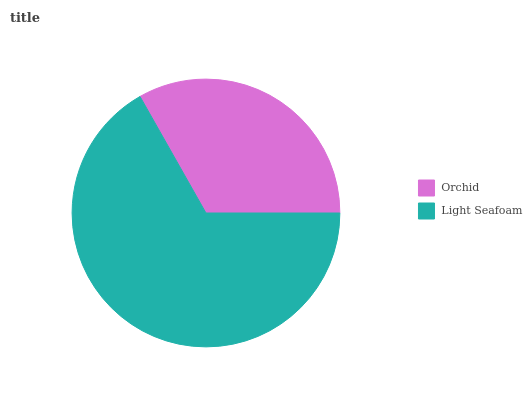Is Orchid the minimum?
Answer yes or no. Yes. Is Light Seafoam the maximum?
Answer yes or no. Yes. Is Light Seafoam the minimum?
Answer yes or no. No. Is Light Seafoam greater than Orchid?
Answer yes or no. Yes. Is Orchid less than Light Seafoam?
Answer yes or no. Yes. Is Orchid greater than Light Seafoam?
Answer yes or no. No. Is Light Seafoam less than Orchid?
Answer yes or no. No. Is Light Seafoam the high median?
Answer yes or no. Yes. Is Orchid the low median?
Answer yes or no. Yes. Is Orchid the high median?
Answer yes or no. No. Is Light Seafoam the low median?
Answer yes or no. No. 